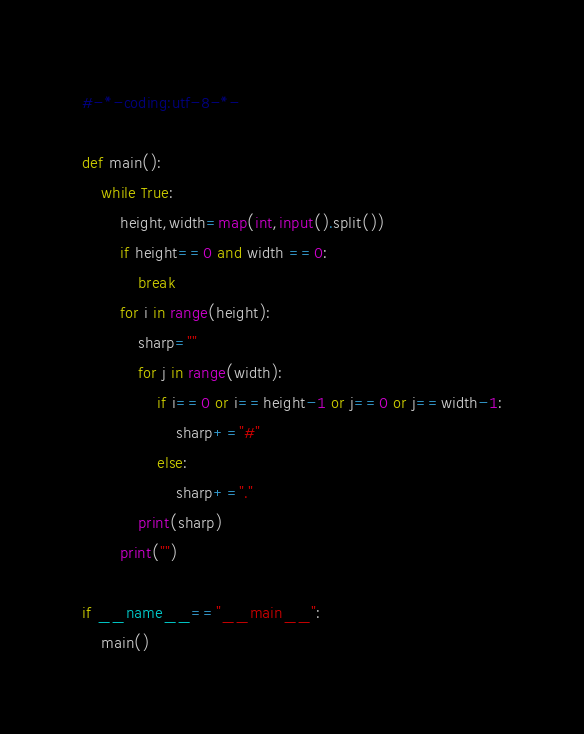Convert code to text. <code><loc_0><loc_0><loc_500><loc_500><_Python_>#-*-coding:utf-8-*-

def main():
    while True:
        height,width=map(int,input().split())
        if height==0 and width ==0:
            break
        for i in range(height):
            sharp=""
            for j in range(width):
                if i==0 or i==height-1 or j==0 or j==width-1:
                    sharp+="#"
                else:
                    sharp+="."
            print(sharp)
        print("")

if __name__=="__main__":
    main()
</code> 